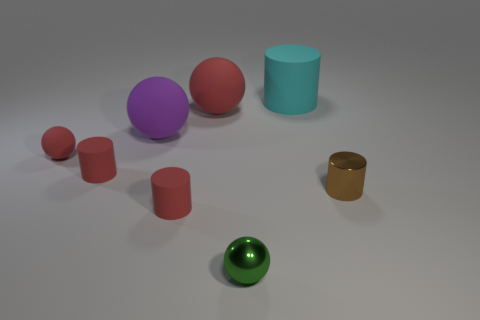Does the cylinder left of the purple thing have the same color as the tiny matte ball?
Your answer should be compact. Yes. There is a small ball in front of the shiny object that is to the right of the sphere that is in front of the brown metallic thing; what is its material?
Provide a succinct answer. Metal. How many other things are there of the same size as the green metallic object?
Your answer should be very brief. 4. The shiny sphere has what color?
Offer a terse response. Green. How many matte things are either purple objects or brown objects?
Provide a short and direct response. 1. How big is the metallic object behind the tiny ball that is to the right of the big matte sphere that is left of the large red thing?
Your answer should be compact. Small. How big is the object that is both on the left side of the purple thing and to the right of the small red sphere?
Provide a succinct answer. Small. There is a metal object that is right of the green metallic thing; is its color the same as the matte ball that is in front of the big purple matte sphere?
Give a very brief answer. No. How many red cylinders are to the left of the purple matte ball?
Offer a terse response. 1. There is a tiny red cylinder behind the shiny thing that is behind the metal sphere; are there any small brown metallic cylinders that are behind it?
Offer a terse response. No. 